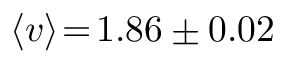Convert formula to latex. <formula><loc_0><loc_0><loc_500><loc_500>\langle v \rangle \, = \, 1 . 8 6 \pm 0 . 0 2</formula> 